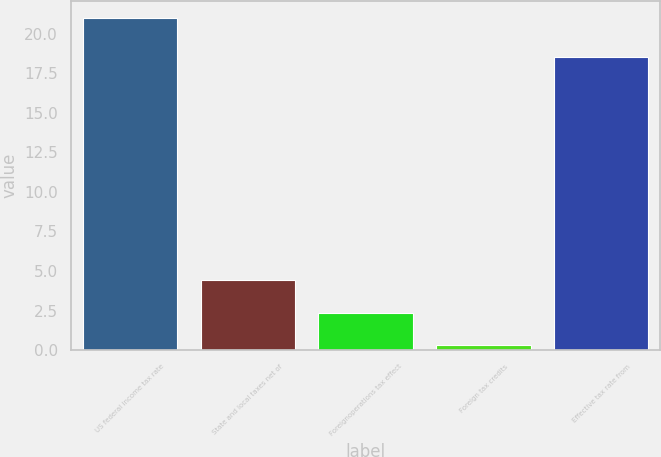Convert chart to OTSL. <chart><loc_0><loc_0><loc_500><loc_500><bar_chart><fcel>US federal income tax rate<fcel>State and local taxes net of<fcel>Foreignoperations tax effect<fcel>Foreign tax credits<fcel>Effective tax rate from<nl><fcel>21<fcel>4.44<fcel>2.37<fcel>0.3<fcel>18.5<nl></chart> 